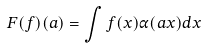Convert formula to latex. <formula><loc_0><loc_0><loc_500><loc_500>F ( f ) ( a ) = \int f ( x ) \alpha ( a x ) d x</formula> 